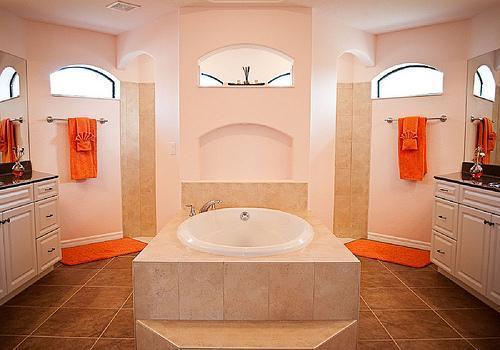How many tubs are in the picture?
Give a very brief answer. 1. 